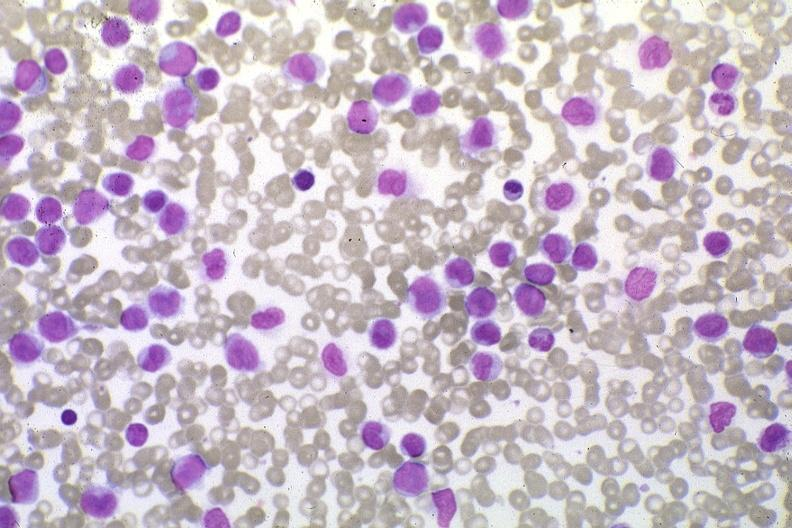s bone, skull present?
Answer the question using a single word or phrase. No 